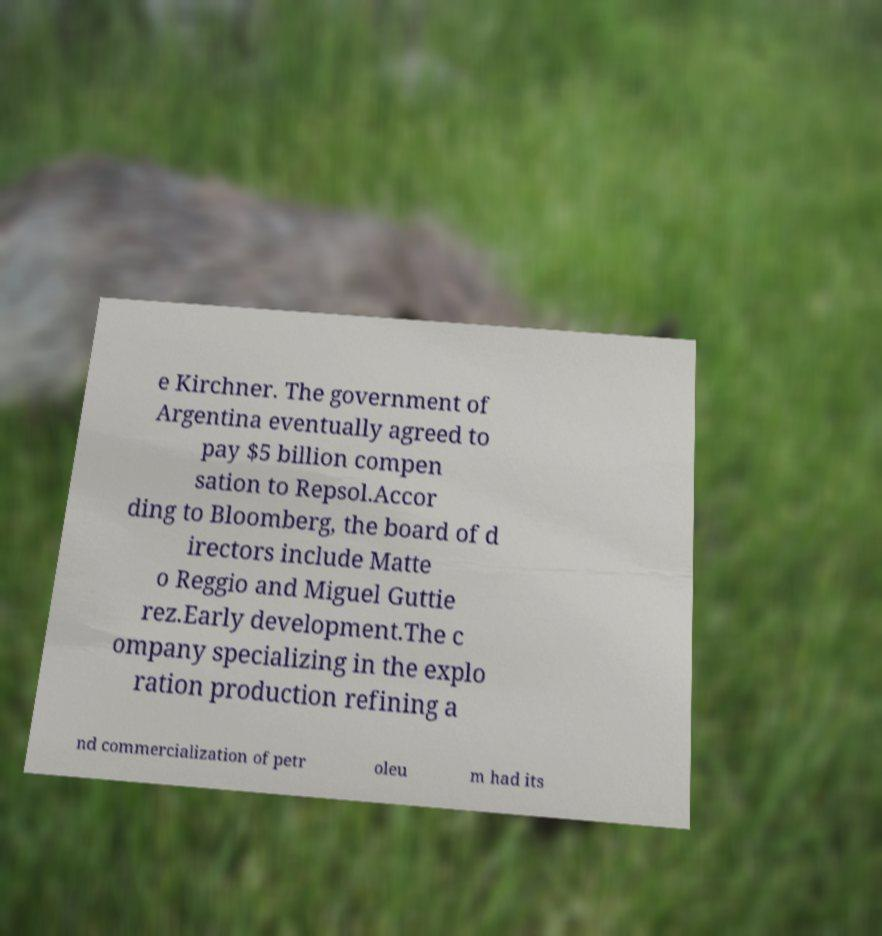Can you accurately transcribe the text from the provided image for me? e Kirchner. The government of Argentina eventually agreed to pay $5 billion compen sation to Repsol.Accor ding to Bloomberg, the board of d irectors include Matte o Reggio and Miguel Guttie rez.Early development.The c ompany specializing in the explo ration production refining a nd commercialization of petr oleu m had its 